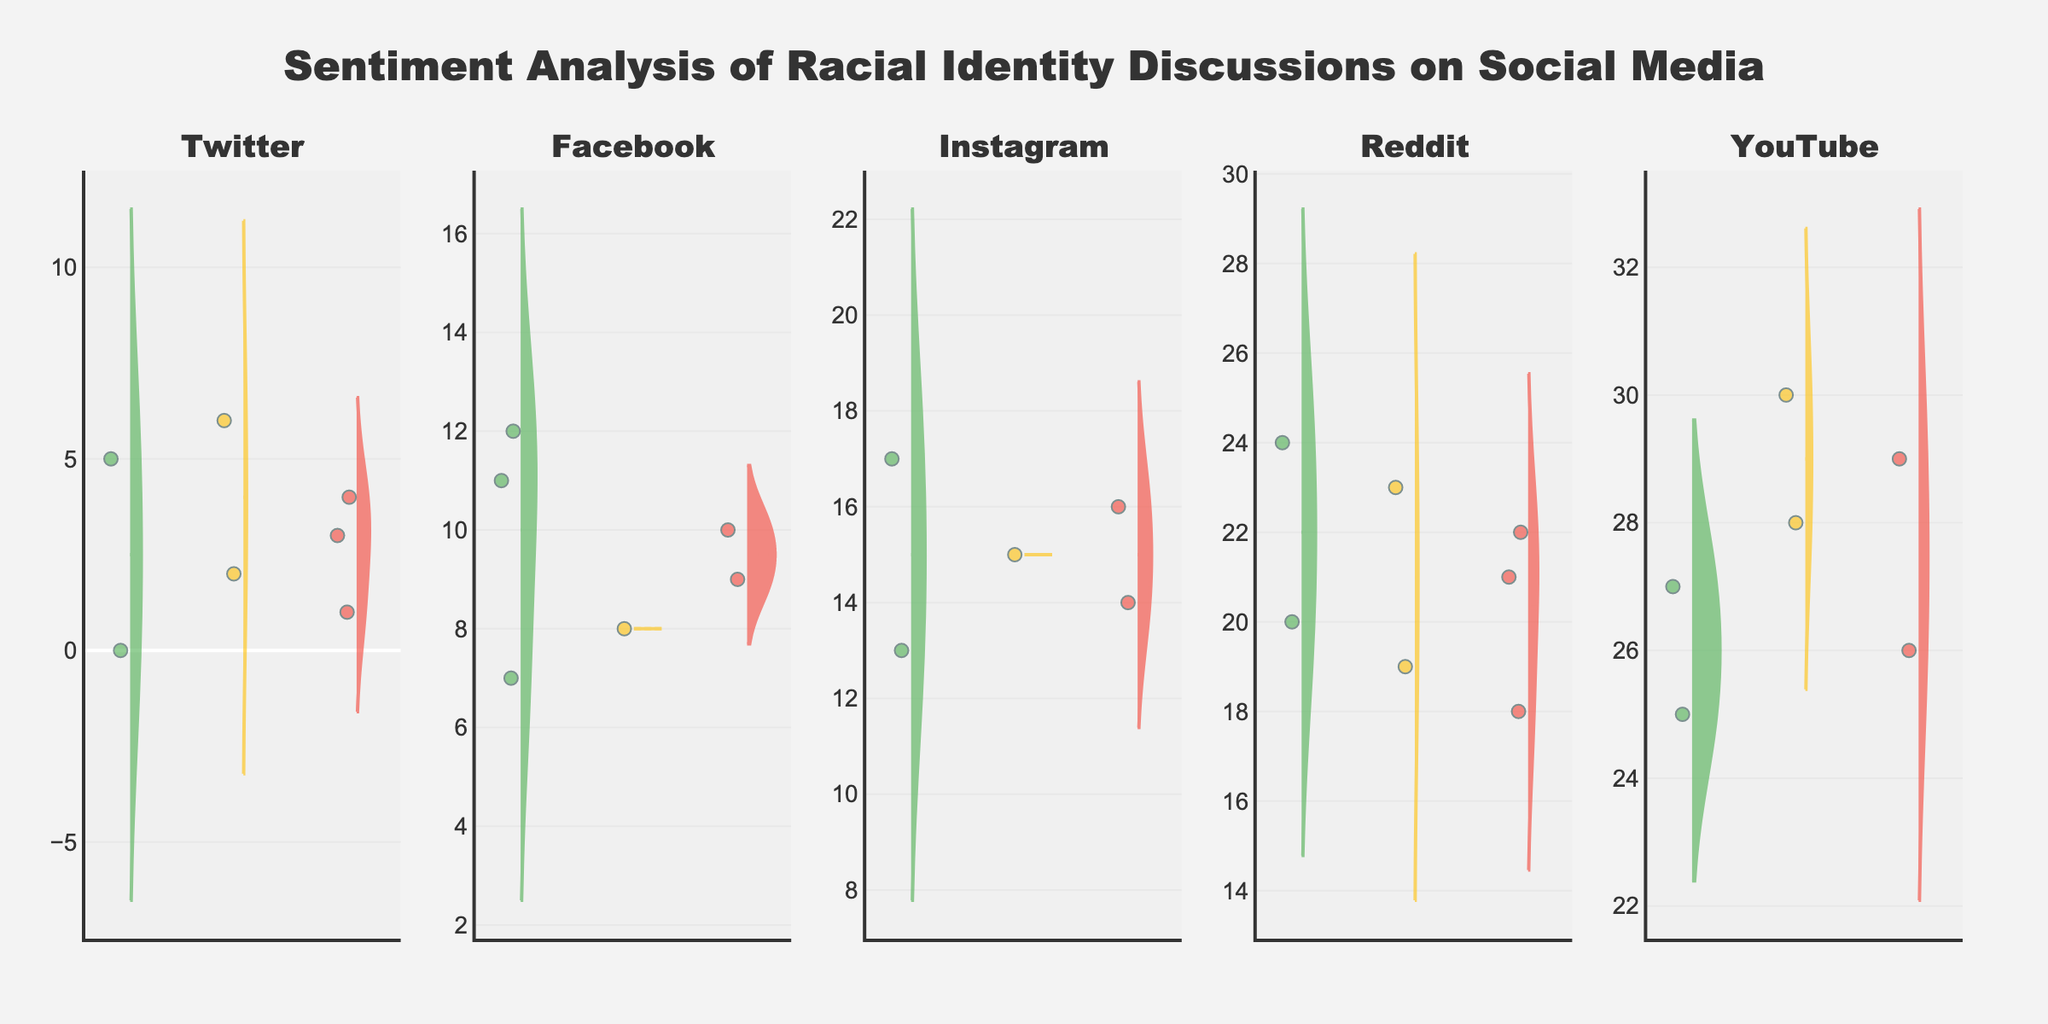what is the title of the figure? The title of the figure is displayed prominently at the top center of the chart. It reads "Sentiment Analysis of Racial Identity Discussions on Social Media," indicating the focus of the analysis.
Answer: Sentiment Analysis of Racial Identity Discussions on Social Media Which social media platform shows the most negative sentiment distribution? Looking at the violins representing negative sentiment for each platform, the one with the widest distribution and most data points indicates the platform with the highest negative sentiment. In this case, Reddit shows the widest negative sentiment distribution.
Answer: Reddit What colors represent positive, neutral, and negative sentiments? The figure uses specific colors to represent different sentiments. Positive sentiment is represented by green, neutral by yellow, and negative by red.
Answer: Green for Positive, Yellow for Neutral, Red for Negative Which platform has the most evenly distributed sentiments? This can be determined by observing the width and spread of the violin plots for each sentiment category per platform. Facebook has relatively balanced and similar-width distributions for positive, neutral, and negative sentiments.
Answer: Facebook How does the distribution of neutral sentiment on Twitter compare to Instagram? To compare neutral sentiment distribution between Twitter and Instagram, we observe the respective violin plots' width and spread for the neutral sentiment. Twitter has a narrower distribution for neutral sentiment compared to Instagram, indicating fewer neutral discussions.
Answer: Twitter has a narrower distribution than Instagram What platform has the highest amount of positive sentiment? Looking at the violin plots for positive sentiment across all platforms, Instagram shows a wider distribution of positive sentiment than the others, indicating a higher amount of positive sentiment.
Answer: Instagram What is the dominant sentiment on YouTube? By observing the violin plots for YouTube, we can see which sentiment has the widest and most extensive distribution. In this case, positive sentiment appears to be the dominant sentiment on YouTube.
Answer: Positive Which platform exhibits the least variation in negative sentiment? Variation in the sentiment can be defined by observing the range and spread of the negative sentiment violin plots. Facebook demonstrates the least variation in negative sentiment as its plot is narrower compared to other platforms.
Answer: Facebook Are there any platforms with no major sentiment disparities? Platforms with no major sentiment disparities will have equally wide or narrow violin plots across all sentiment categories. Facebook is closest to having no major disparities with fairly balanced distributions across all sentiments.
Answer: Facebook Compare the average sentiment on Twitter versus Reddit. To compare average sentiment, we need to visually gauge the center of the distribution (mean lines) across sentiments. Twitter's mean lines for negative sentiment appear to be lower, while positive and neutral distributions are similar to Reddit. However, Reddit shows a more dominant negative sentiment overall.
Answer: Twitter has higher negative sentiment, comparable positive and neutral sentiment 